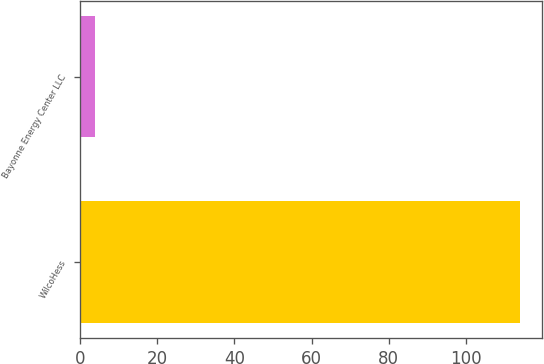Convert chart. <chart><loc_0><loc_0><loc_500><loc_500><bar_chart><fcel>WilcoHess<fcel>Bayonne Energy Center LLC<nl><fcel>114<fcel>4<nl></chart> 